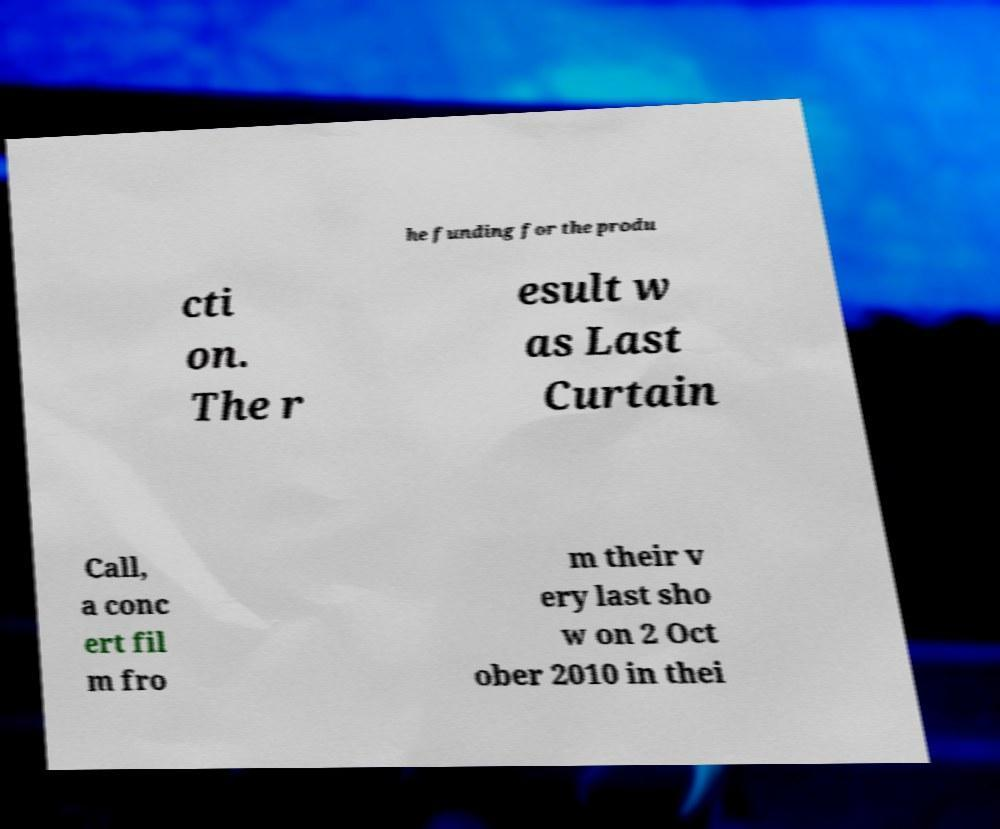Please identify and transcribe the text found in this image. he funding for the produ cti on. The r esult w as Last Curtain Call, a conc ert fil m fro m their v ery last sho w on 2 Oct ober 2010 in thei 